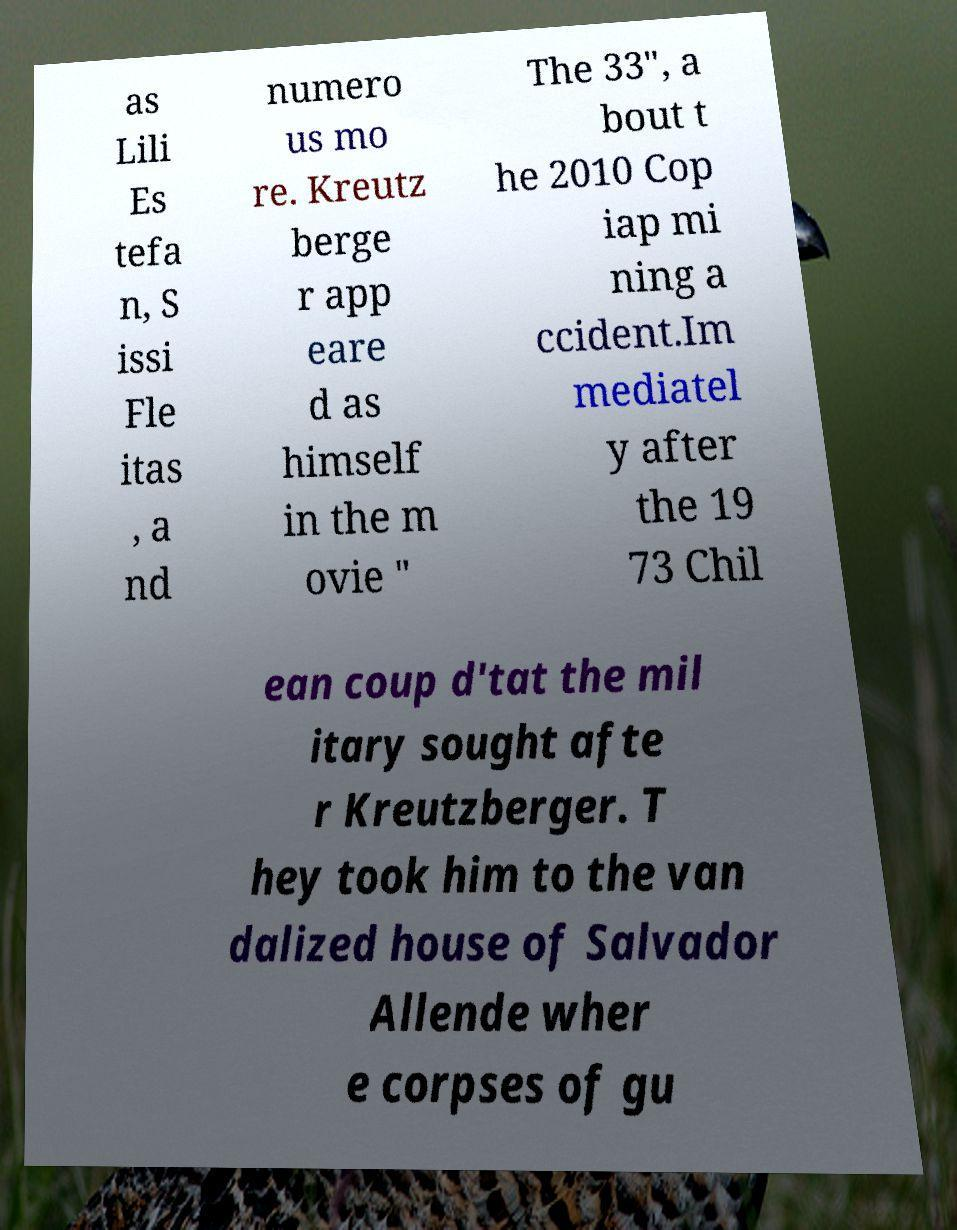What messages or text are displayed in this image? I need them in a readable, typed format. as Lili Es tefa n, S issi Fle itas , a nd numero us mo re. Kreutz berge r app eare d as himself in the m ovie " The 33", a bout t he 2010 Cop iap mi ning a ccident.Im mediatel y after the 19 73 Chil ean coup d'tat the mil itary sought afte r Kreutzberger. T hey took him to the van dalized house of Salvador Allende wher e corpses of gu 